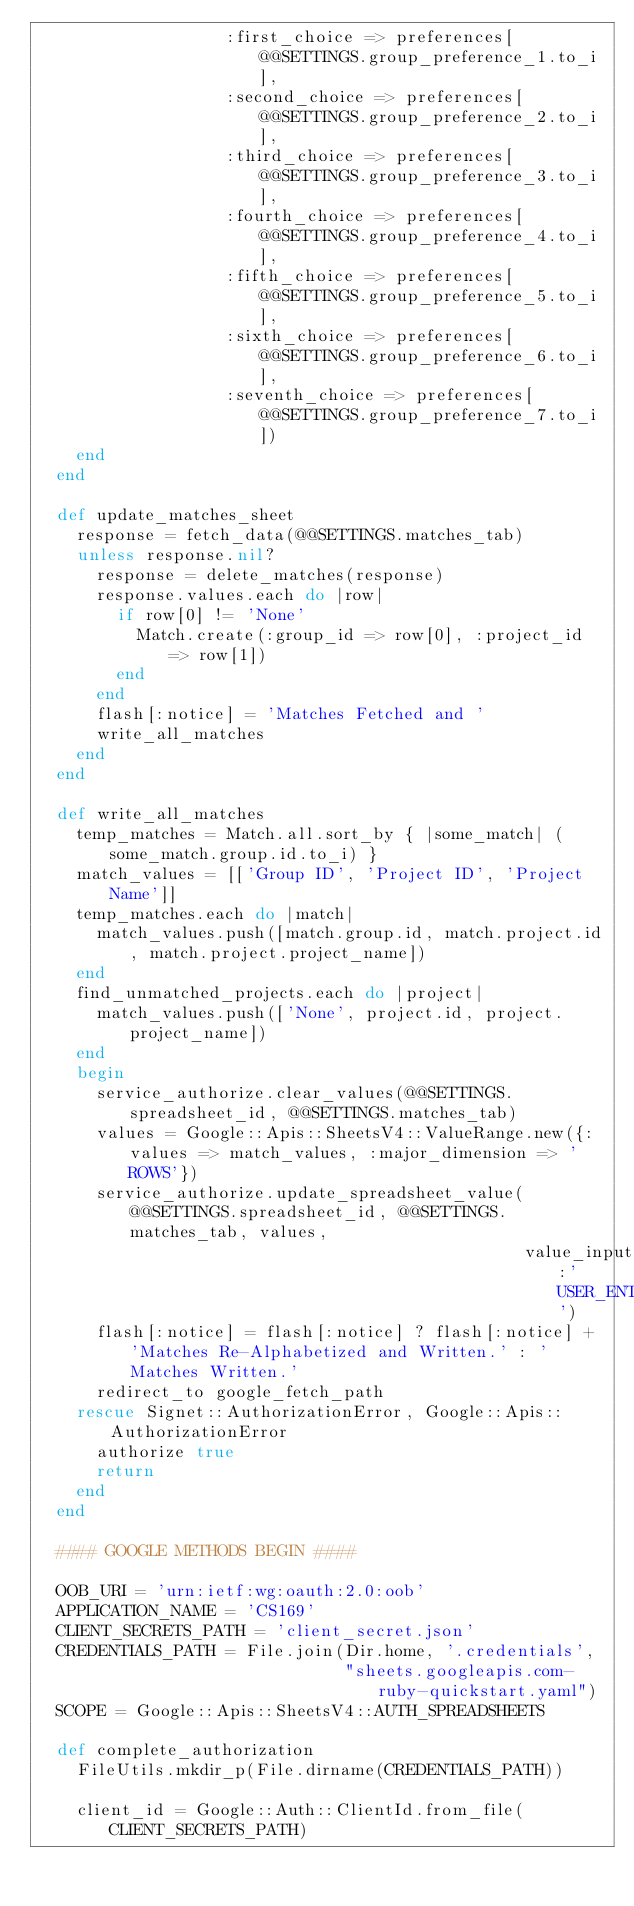<code> <loc_0><loc_0><loc_500><loc_500><_Ruby_>                   :first_choice => preferences[@@SETTINGS.group_preference_1.to_i],
                   :second_choice => preferences[@@SETTINGS.group_preference_2.to_i],
                   :third_choice => preferences[@@SETTINGS.group_preference_3.to_i],
                   :fourth_choice => preferences[@@SETTINGS.group_preference_4.to_i],
                   :fifth_choice => preferences[@@SETTINGS.group_preference_5.to_i],
                   :sixth_choice => preferences[@@SETTINGS.group_preference_6.to_i],
                   :seventh_choice => preferences[@@SETTINGS.group_preference_7.to_i])
    end
  end

  def update_matches_sheet
    response = fetch_data(@@SETTINGS.matches_tab)
    unless response.nil?
      response = delete_matches(response)
      response.values.each do |row|
        if row[0] != 'None'
          Match.create(:group_id => row[0], :project_id => row[1])
        end
      end
      flash[:notice] = 'Matches Fetched and '
      write_all_matches
    end
  end

  def write_all_matches
    temp_matches = Match.all.sort_by { |some_match| (some_match.group.id.to_i) }
    match_values = [['Group ID', 'Project ID', 'Project Name']]
    temp_matches.each do |match|
      match_values.push([match.group.id, match.project.id, match.project.project_name])
    end
    find_unmatched_projects.each do |project|
      match_values.push(['None', project.id, project.project_name])
    end
    begin
      service_authorize.clear_values(@@SETTINGS.spreadsheet_id, @@SETTINGS.matches_tab)
      values = Google::Apis::SheetsV4::ValueRange.new({:values => match_values, :major_dimension => 'ROWS'})
      service_authorize.update_spreadsheet_value(@@SETTINGS.spreadsheet_id, @@SETTINGS.matches_tab, values,
                                                 value_input_option:'USER_ENTERED')
      flash[:notice] = flash[:notice] ? flash[:notice] + 'Matches Re-Alphabetized and Written.' : 'Matches Written.'
      redirect_to google_fetch_path
    rescue Signet::AuthorizationError, Google::Apis::AuthorizationError
      authorize true
      return
    end
  end

  #### GOOGLE METHODS BEGIN ####

  OOB_URI = 'urn:ietf:wg:oauth:2.0:oob'
  APPLICATION_NAME = 'CS169'
  CLIENT_SECRETS_PATH = 'client_secret.json'
  CREDENTIALS_PATH = File.join(Dir.home, '.credentials',
                               "sheets.googleapis.com-ruby-quickstart.yaml")
  SCOPE = Google::Apis::SheetsV4::AUTH_SPREADSHEETS

  def complete_authorization
    FileUtils.mkdir_p(File.dirname(CREDENTIALS_PATH))

    client_id = Google::Auth::ClientId.from_file(CLIENT_SECRETS_PATH)</code> 